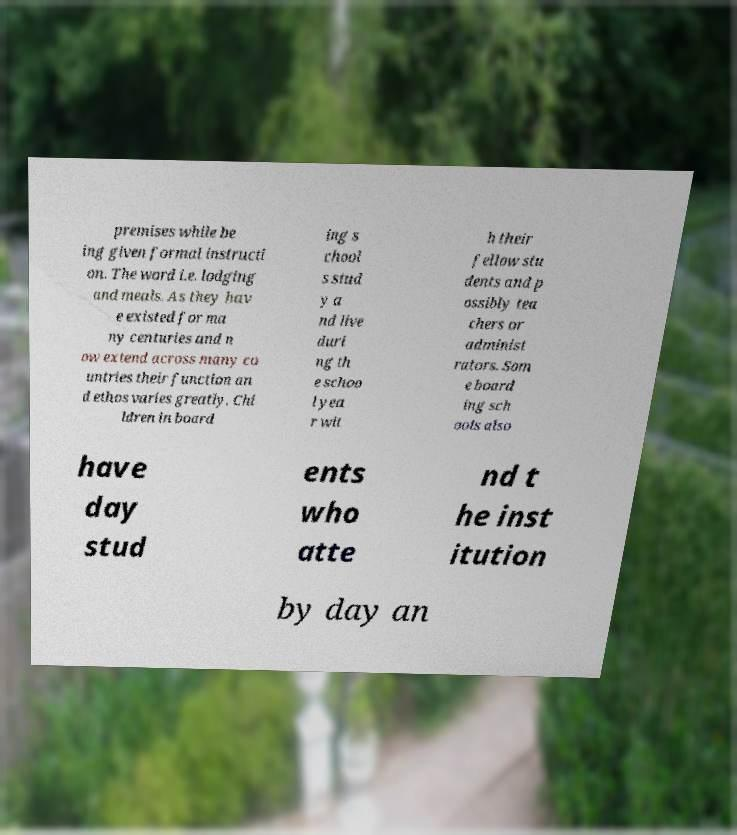Could you extract and type out the text from this image? premises while be ing given formal instructi on. The word i.e. lodging and meals. As they hav e existed for ma ny centuries and n ow extend across many co untries their function an d ethos varies greatly. Chi ldren in board ing s chool s stud y a nd live duri ng th e schoo l yea r wit h their fellow stu dents and p ossibly tea chers or administ rators. Som e board ing sch ools also have day stud ents who atte nd t he inst itution by day an 